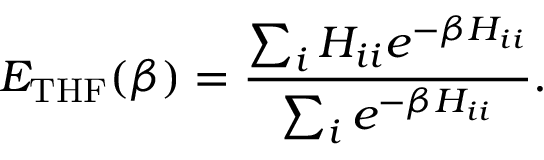<formula> <loc_0><loc_0><loc_500><loc_500>E _ { T H F } ( \beta ) = \frac { \sum _ { i } H _ { i i } e ^ { - \beta H _ { i i } } } { \sum _ { i } e ^ { - \beta H _ { i i } } } .</formula> 